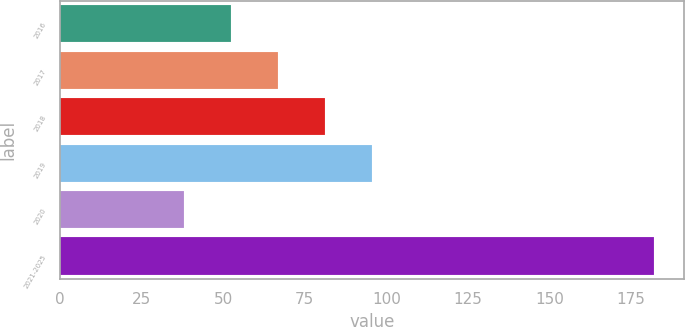Convert chart to OTSL. <chart><loc_0><loc_0><loc_500><loc_500><bar_chart><fcel>2016<fcel>2017<fcel>2018<fcel>2019<fcel>2020<fcel>2021-2025<nl><fcel>52.4<fcel>66.8<fcel>81.2<fcel>95.6<fcel>38<fcel>182<nl></chart> 